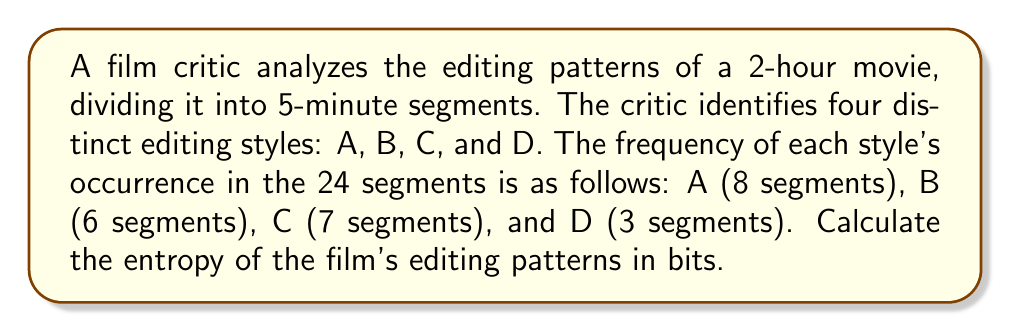Could you help me with this problem? To calculate the entropy of the film's editing patterns, we'll use the Shannon entropy formula:

$$S = -\sum_{i} p_i \log_2(p_i)$$

Where $p_i$ is the probability of each editing style occurring.

Step 1: Calculate the probabilities for each editing style
Total segments: 24
$p_A = 8/24 = 1/3$
$p_B = 6/24 = 1/4$
$p_C = 7/24 = 7/24$
$p_D = 3/24 = 1/8$

Step 2: Apply the entropy formula
$$S = -(\frac{1}{3} \log_2(\frac{1}{3}) + \frac{1}{4} \log_2(\frac{1}{4}) + \frac{7}{24} \log_2(\frac{7}{24}) + \frac{1}{8} \log_2(\frac{1}{8}))$$

Step 3: Calculate each term
$\frac{1}{3} \log_2(\frac{1}{3}) \approx 0.5283$
$\frac{1}{4} \log_2(\frac{1}{4}) = 0.5$
$\frac{7}{24} \log_2(\frac{7}{24}) \approx 0.4621$
$\frac{1}{8} \log_2(\frac{1}{8}) = 0.375$

Step 4: Sum the negative of these values
$$S = -((-0.5283) + (-0.5) + (-0.4621) + (-0.375))$$
$$S = 0.5283 + 0.5 + 0.4621 + 0.375$$
$$S \approx 1.8654 \text{ bits}$$
Answer: 1.8654 bits 